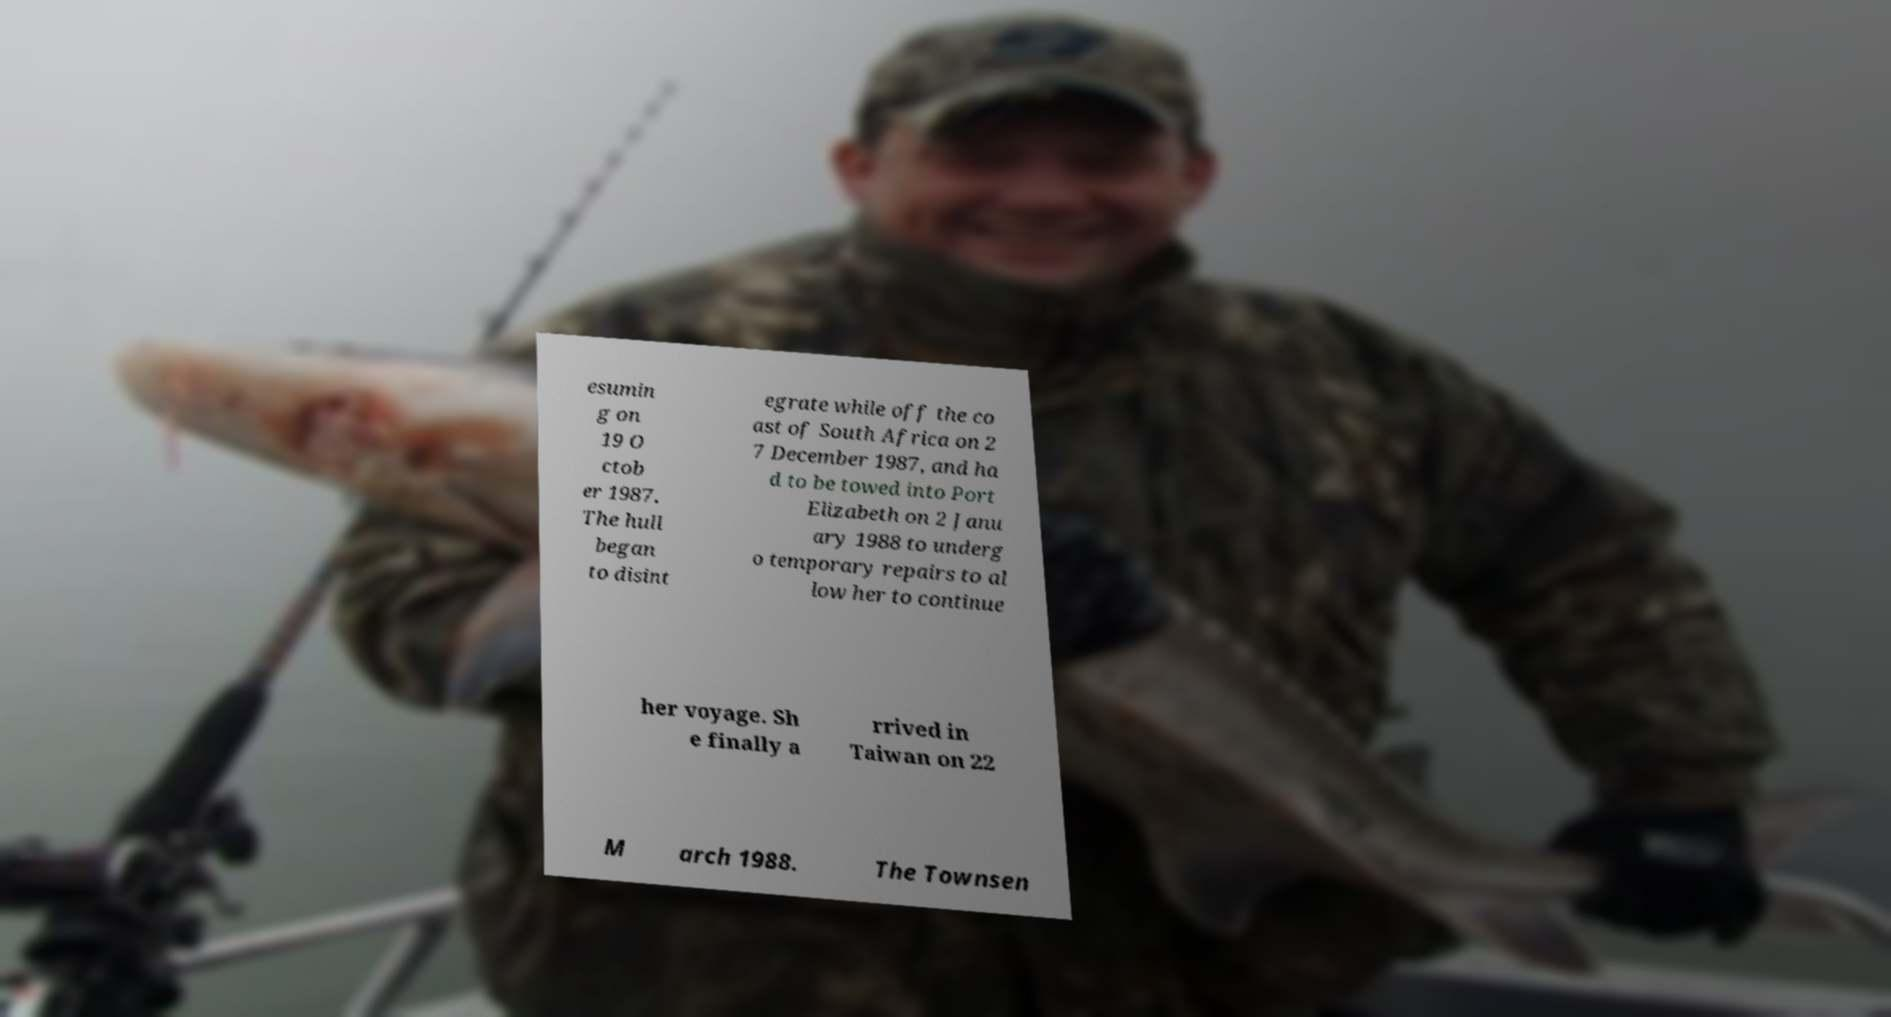Please read and relay the text visible in this image. What does it say? esumin g on 19 O ctob er 1987. The hull began to disint egrate while off the co ast of South Africa on 2 7 December 1987, and ha d to be towed into Port Elizabeth on 2 Janu ary 1988 to underg o temporary repairs to al low her to continue her voyage. Sh e finally a rrived in Taiwan on 22 M arch 1988. The Townsen 